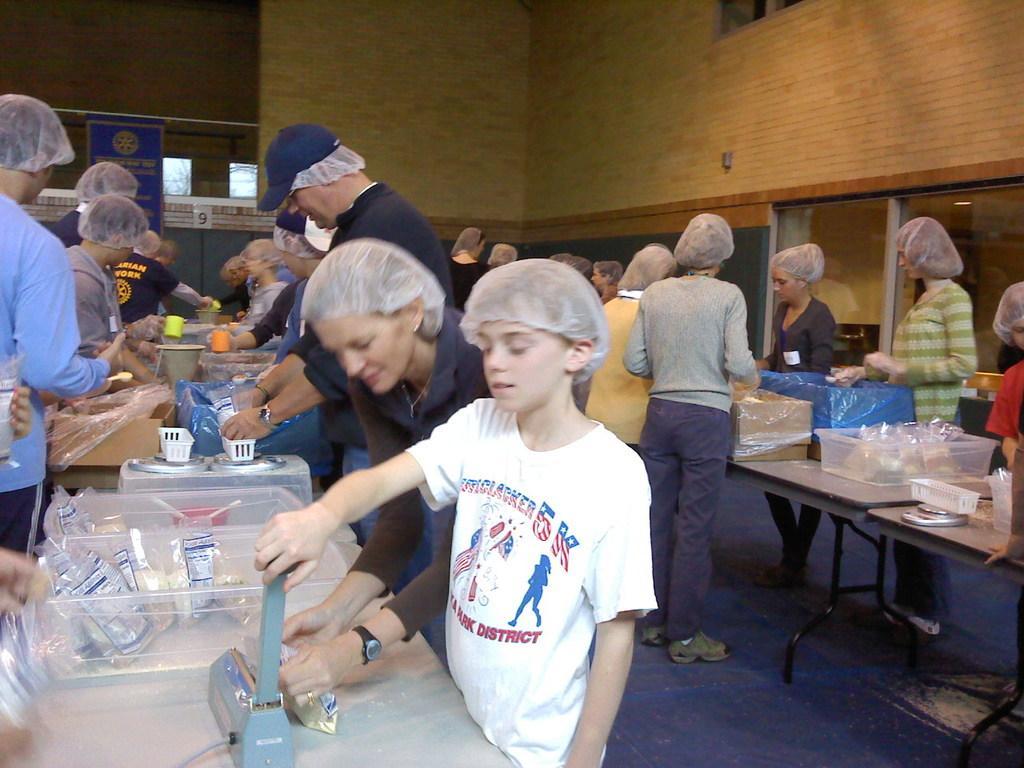Can you describe this image briefly? In this picture we can see some persons standing on the floor. This is table. On the table there is a box. He wear a cap and on the background there is a wall. 